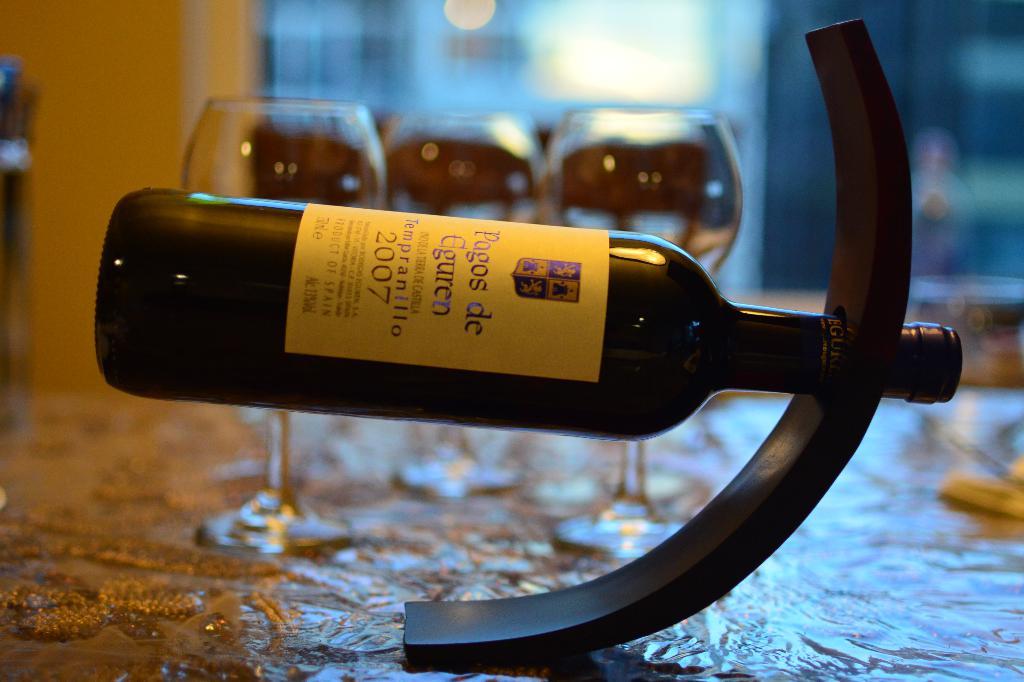What country is on the wine label?
Provide a succinct answer. Spain. 